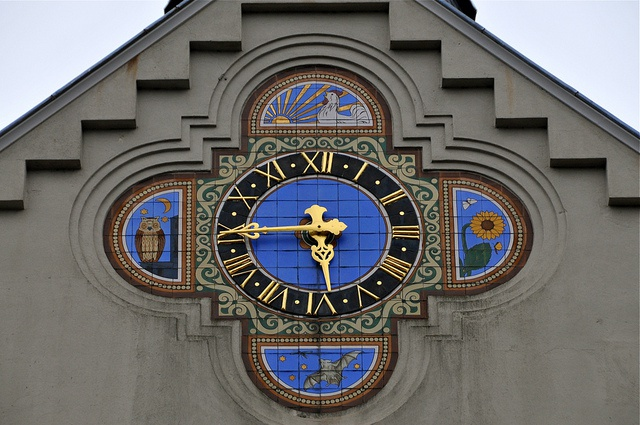Describe the objects in this image and their specific colors. I can see a clock in lavender, black, blue, khaki, and darkgray tones in this image. 